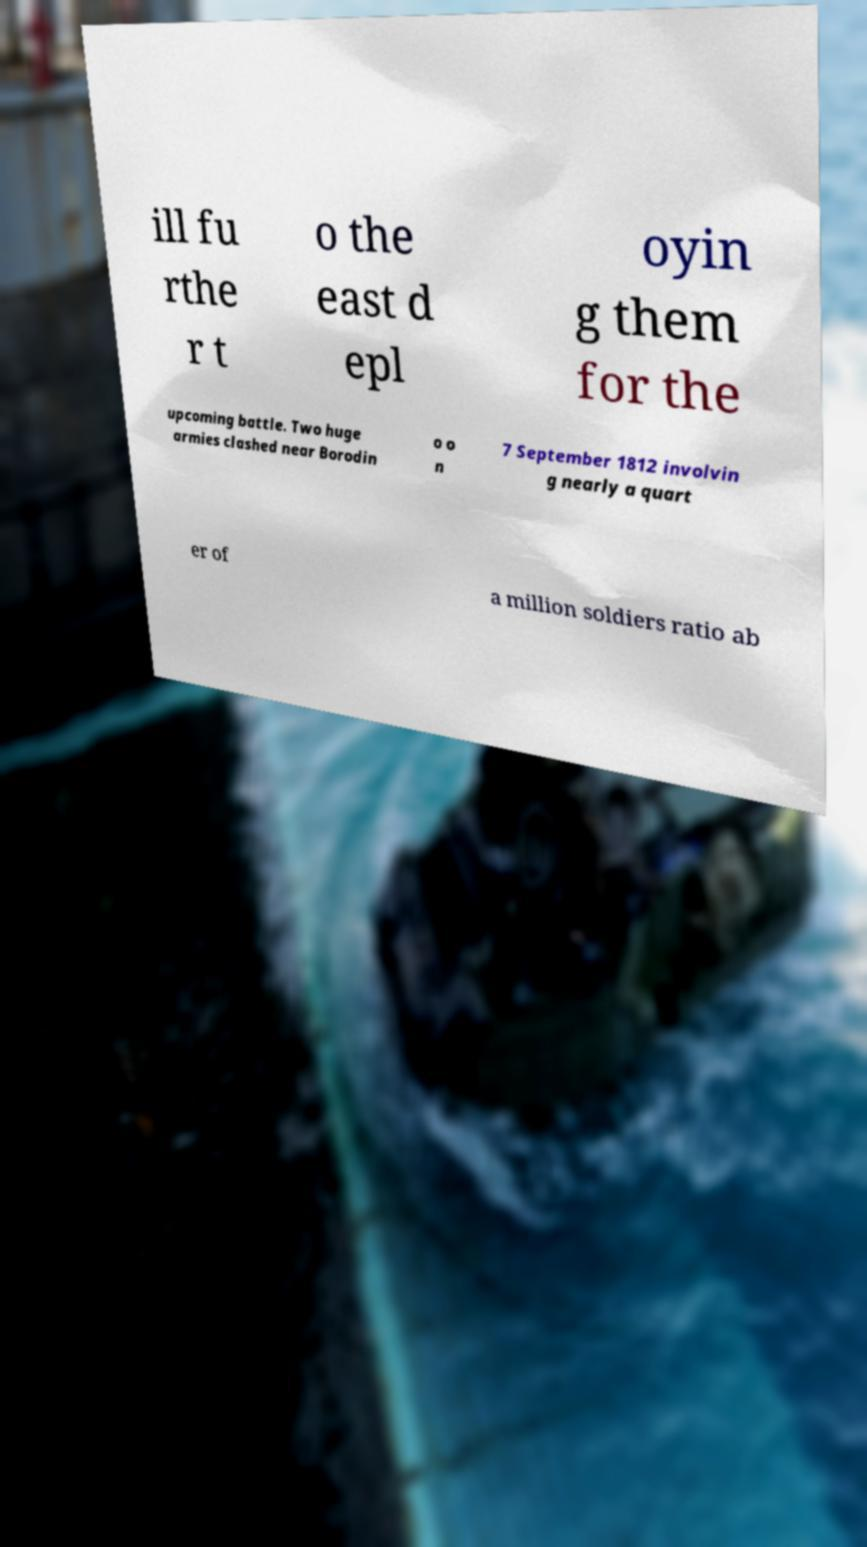There's text embedded in this image that I need extracted. Can you transcribe it verbatim? ill fu rthe r t o the east d epl oyin g them for the upcoming battle. Two huge armies clashed near Borodin o o n 7 September 1812 involvin g nearly a quart er of a million soldiers ratio ab 